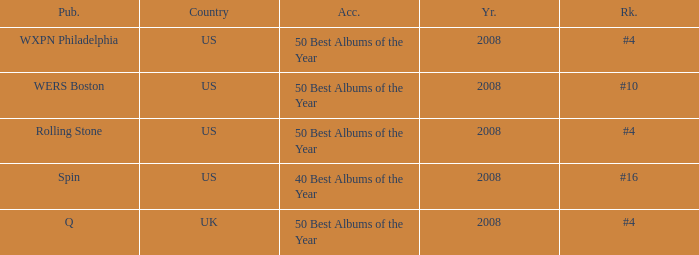Which publication happened in the UK? Q. 